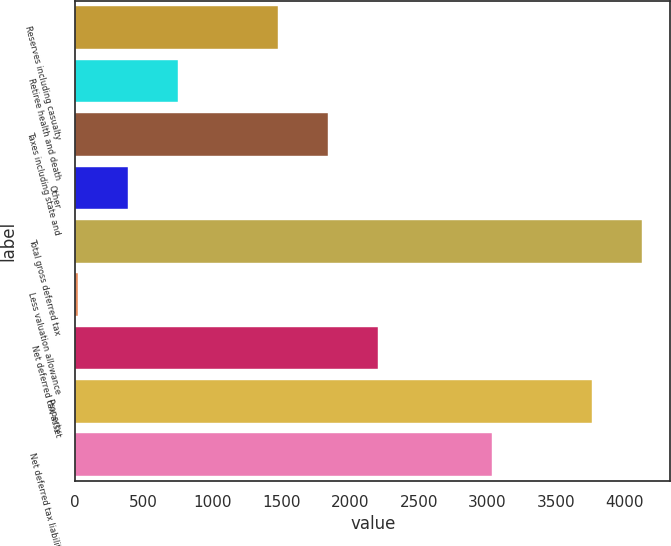<chart> <loc_0><loc_0><loc_500><loc_500><bar_chart><fcel>Reserves including casualty<fcel>Retiree health and death<fcel>Taxes including state and<fcel>Other<fcel>Total gross deferred tax<fcel>Less valuation allowance<fcel>Net deferred tax asset<fcel>Property<fcel>Net deferred tax liability<nl><fcel>1476.4<fcel>749.2<fcel>1840<fcel>385.6<fcel>4124.8<fcel>22<fcel>2203.6<fcel>3761.2<fcel>3034<nl></chart> 